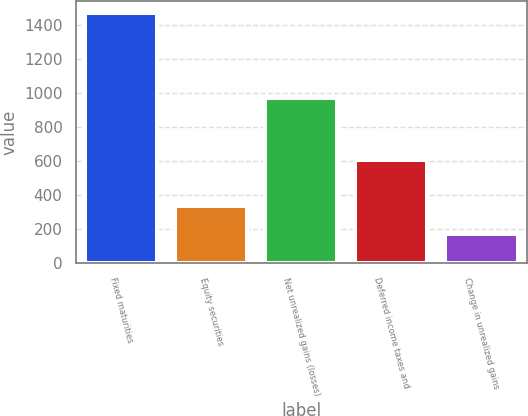Convert chart to OTSL. <chart><loc_0><loc_0><loc_500><loc_500><bar_chart><fcel>Fixed maturities<fcel>Equity securities<fcel>Net unrealized gains (losses)<fcel>Deferred income taxes and<fcel>Change in unrealized gains<nl><fcel>1466<fcel>336.4<fcel>969<fcel>608<fcel>170.2<nl></chart> 